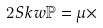<formula> <loc_0><loc_0><loc_500><loc_500>2 S k w \mathbb { P } = \mu \times</formula> 